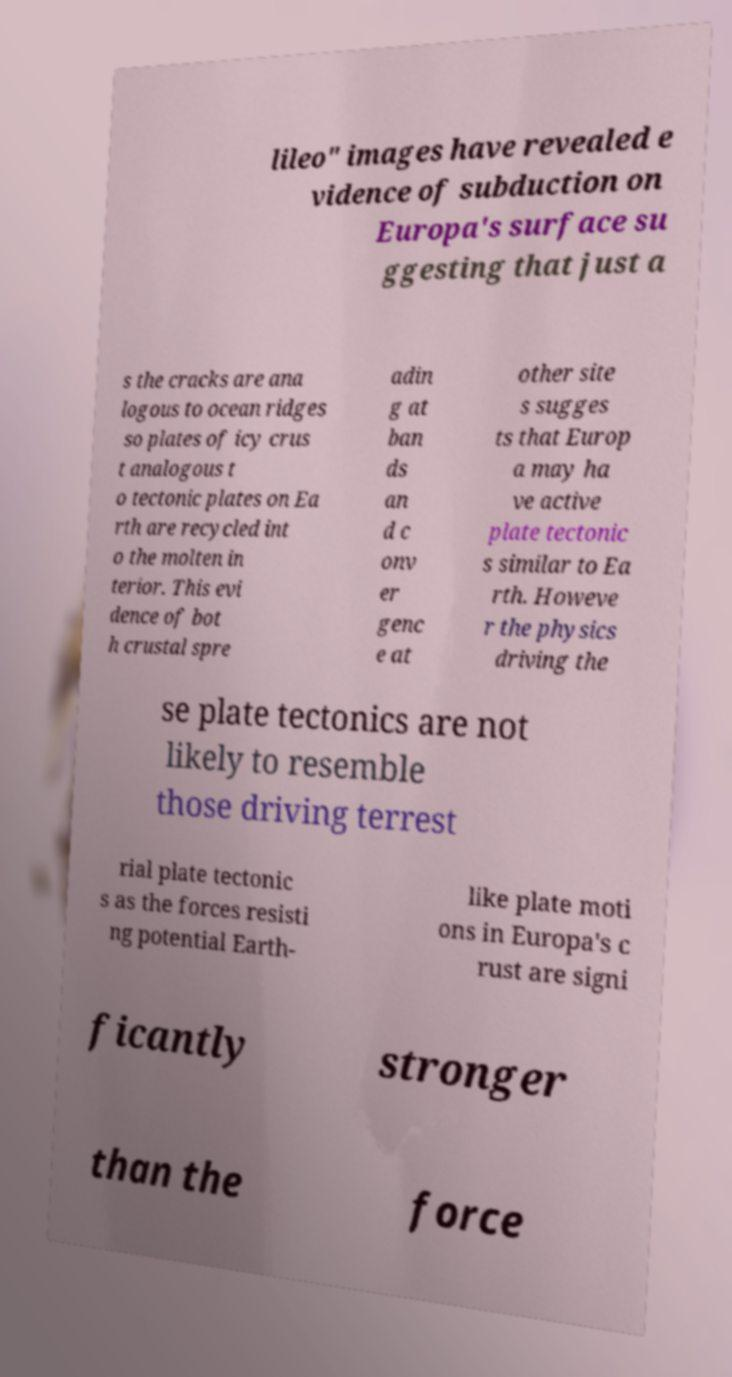What messages or text are displayed in this image? I need them in a readable, typed format. lileo" images have revealed e vidence of subduction on Europa's surface su ggesting that just a s the cracks are ana logous to ocean ridges so plates of icy crus t analogous t o tectonic plates on Ea rth are recycled int o the molten in terior. This evi dence of bot h crustal spre adin g at ban ds an d c onv er genc e at other site s sugges ts that Europ a may ha ve active plate tectonic s similar to Ea rth. Howeve r the physics driving the se plate tectonics are not likely to resemble those driving terrest rial plate tectonic s as the forces resisti ng potential Earth- like plate moti ons in Europa's c rust are signi ficantly stronger than the force 